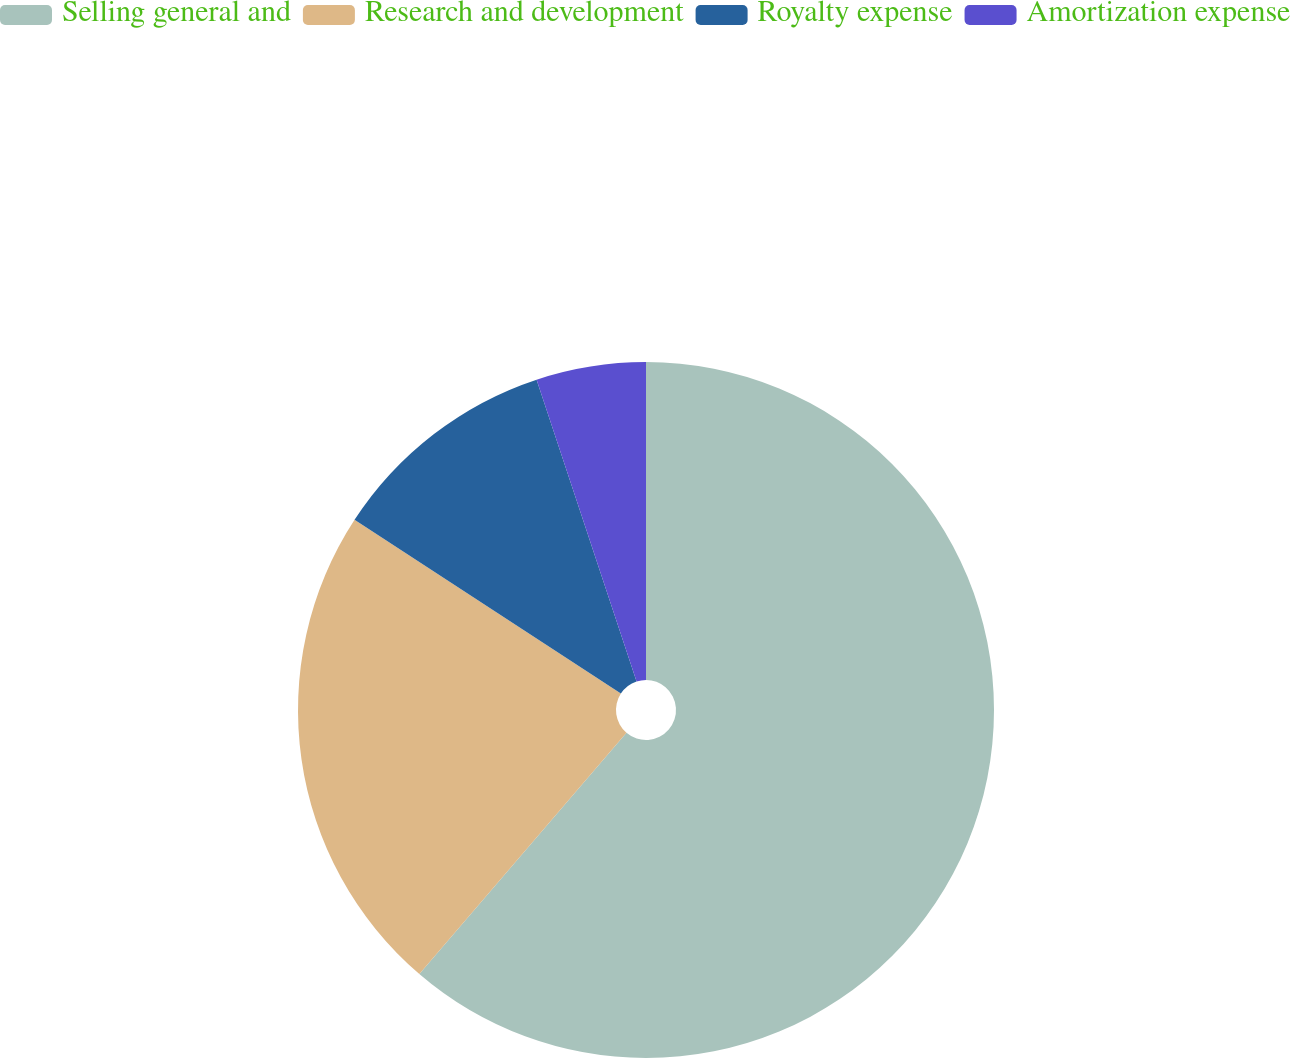<chart> <loc_0><loc_0><loc_500><loc_500><pie_chart><fcel>Selling general and<fcel>Research and development<fcel>Royalty expense<fcel>Amortization expense<nl><fcel>61.29%<fcel>22.91%<fcel>10.71%<fcel>5.09%<nl></chart> 